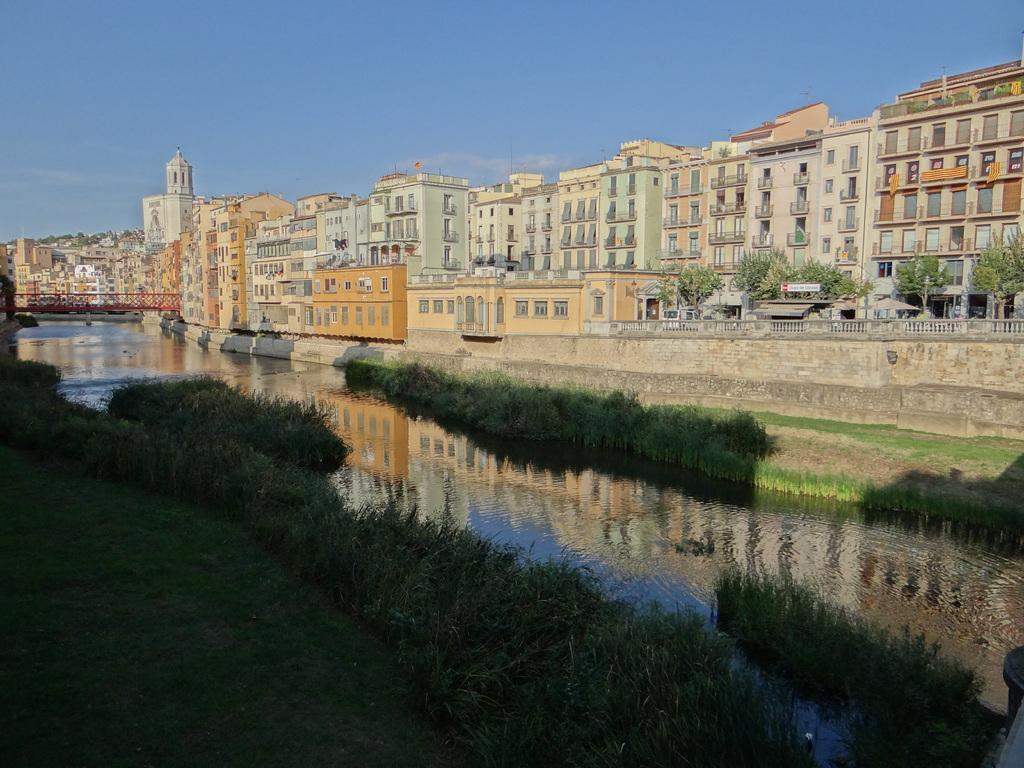What type of vegetation is present in the image? There is grass in the image. What natural element is also present in the image? There is water in the image. What man-made structures can be seen in the image? There are buildings and a bridge in the image. What is the color of the sky in the background of the image? The sky in the background of the image is blue. Where is the dog collecting honey in the image? There is no dog or honey present in the image. 